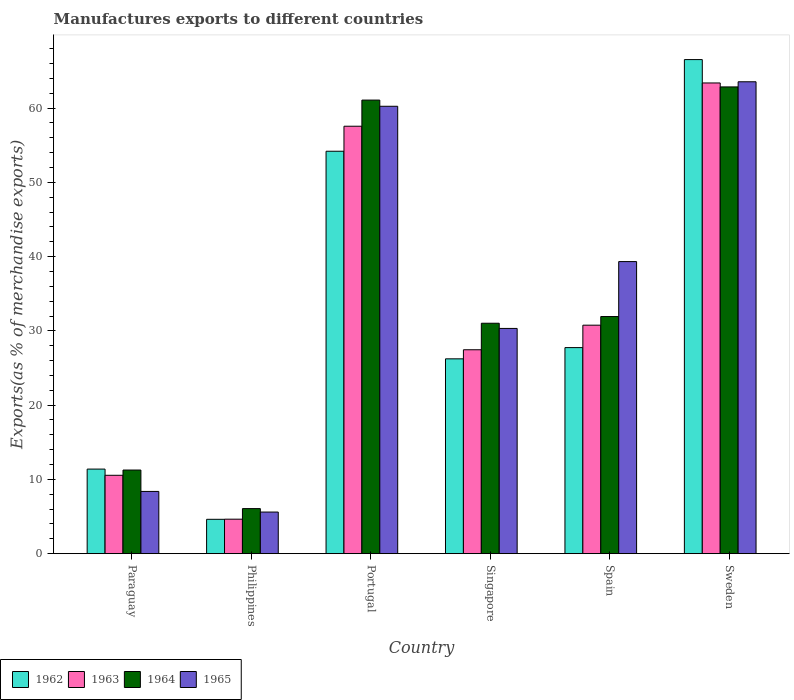How many different coloured bars are there?
Ensure brevity in your answer.  4. How many groups of bars are there?
Your answer should be very brief. 6. How many bars are there on the 5th tick from the left?
Offer a terse response. 4. What is the label of the 4th group of bars from the left?
Provide a succinct answer. Singapore. In how many cases, is the number of bars for a given country not equal to the number of legend labels?
Your response must be concise. 0. What is the percentage of exports to different countries in 1963 in Paraguay?
Offer a terse response. 10.55. Across all countries, what is the maximum percentage of exports to different countries in 1963?
Keep it short and to the point. 63.39. Across all countries, what is the minimum percentage of exports to different countries in 1962?
Your response must be concise. 4.63. In which country was the percentage of exports to different countries in 1962 maximum?
Make the answer very short. Sweden. What is the total percentage of exports to different countries in 1965 in the graph?
Offer a terse response. 207.45. What is the difference between the percentage of exports to different countries in 1963 in Philippines and that in Spain?
Give a very brief answer. -26.13. What is the difference between the percentage of exports to different countries in 1963 in Paraguay and the percentage of exports to different countries in 1965 in Portugal?
Your answer should be compact. -49.7. What is the average percentage of exports to different countries in 1964 per country?
Your response must be concise. 34.04. What is the difference between the percentage of exports to different countries of/in 1965 and percentage of exports to different countries of/in 1962 in Spain?
Offer a very short reply. 11.58. In how many countries, is the percentage of exports to different countries in 1965 greater than 40 %?
Make the answer very short. 2. What is the ratio of the percentage of exports to different countries in 1964 in Portugal to that in Spain?
Keep it short and to the point. 1.91. Is the difference between the percentage of exports to different countries in 1965 in Paraguay and Philippines greater than the difference between the percentage of exports to different countries in 1962 in Paraguay and Philippines?
Provide a succinct answer. No. What is the difference between the highest and the second highest percentage of exports to different countries in 1964?
Offer a terse response. -1.77. What is the difference between the highest and the lowest percentage of exports to different countries in 1965?
Your answer should be compact. 57.95. Is it the case that in every country, the sum of the percentage of exports to different countries in 1962 and percentage of exports to different countries in 1963 is greater than the sum of percentage of exports to different countries in 1965 and percentage of exports to different countries in 1964?
Offer a very short reply. No. What does the 3rd bar from the left in Sweden represents?
Make the answer very short. 1964. What does the 1st bar from the right in Paraguay represents?
Keep it short and to the point. 1965. How many countries are there in the graph?
Provide a short and direct response. 6. Does the graph contain any zero values?
Ensure brevity in your answer.  No. How are the legend labels stacked?
Give a very brief answer. Horizontal. What is the title of the graph?
Give a very brief answer. Manufactures exports to different countries. Does "1991" appear as one of the legend labels in the graph?
Your answer should be very brief. No. What is the label or title of the Y-axis?
Offer a very short reply. Exports(as % of merchandise exports). What is the Exports(as % of merchandise exports) in 1962 in Paraguay?
Make the answer very short. 11.39. What is the Exports(as % of merchandise exports) of 1963 in Paraguay?
Offer a very short reply. 10.55. What is the Exports(as % of merchandise exports) in 1964 in Paraguay?
Offer a terse response. 11.26. What is the Exports(as % of merchandise exports) in 1965 in Paraguay?
Offer a very short reply. 8.38. What is the Exports(as % of merchandise exports) in 1962 in Philippines?
Your answer should be very brief. 4.63. What is the Exports(as % of merchandise exports) in 1963 in Philippines?
Provide a succinct answer. 4.64. What is the Exports(as % of merchandise exports) in 1964 in Philippines?
Offer a terse response. 6.07. What is the Exports(as % of merchandise exports) in 1965 in Philippines?
Your response must be concise. 5.6. What is the Exports(as % of merchandise exports) of 1962 in Portugal?
Provide a short and direct response. 54.19. What is the Exports(as % of merchandise exports) of 1963 in Portugal?
Ensure brevity in your answer.  57.56. What is the Exports(as % of merchandise exports) in 1964 in Portugal?
Your answer should be very brief. 61.08. What is the Exports(as % of merchandise exports) of 1965 in Portugal?
Ensure brevity in your answer.  60.25. What is the Exports(as % of merchandise exports) of 1962 in Singapore?
Your response must be concise. 26.24. What is the Exports(as % of merchandise exports) of 1963 in Singapore?
Your response must be concise. 27.46. What is the Exports(as % of merchandise exports) of 1964 in Singapore?
Offer a terse response. 31.03. What is the Exports(as % of merchandise exports) in 1965 in Singapore?
Offer a terse response. 30.33. What is the Exports(as % of merchandise exports) of 1962 in Spain?
Ensure brevity in your answer.  27.75. What is the Exports(as % of merchandise exports) in 1963 in Spain?
Give a very brief answer. 30.77. What is the Exports(as % of merchandise exports) of 1964 in Spain?
Keep it short and to the point. 31.93. What is the Exports(as % of merchandise exports) of 1965 in Spain?
Your answer should be compact. 39.33. What is the Exports(as % of merchandise exports) in 1962 in Sweden?
Offer a very short reply. 66.54. What is the Exports(as % of merchandise exports) of 1963 in Sweden?
Keep it short and to the point. 63.39. What is the Exports(as % of merchandise exports) in 1964 in Sweden?
Ensure brevity in your answer.  62.86. What is the Exports(as % of merchandise exports) of 1965 in Sweden?
Provide a succinct answer. 63.55. Across all countries, what is the maximum Exports(as % of merchandise exports) of 1962?
Keep it short and to the point. 66.54. Across all countries, what is the maximum Exports(as % of merchandise exports) of 1963?
Provide a succinct answer. 63.39. Across all countries, what is the maximum Exports(as % of merchandise exports) of 1964?
Make the answer very short. 62.86. Across all countries, what is the maximum Exports(as % of merchandise exports) in 1965?
Your response must be concise. 63.55. Across all countries, what is the minimum Exports(as % of merchandise exports) in 1962?
Offer a very short reply. 4.63. Across all countries, what is the minimum Exports(as % of merchandise exports) of 1963?
Ensure brevity in your answer.  4.64. Across all countries, what is the minimum Exports(as % of merchandise exports) in 1964?
Your answer should be compact. 6.07. Across all countries, what is the minimum Exports(as % of merchandise exports) of 1965?
Your answer should be very brief. 5.6. What is the total Exports(as % of merchandise exports) of 1962 in the graph?
Offer a very short reply. 190.73. What is the total Exports(as % of merchandise exports) in 1963 in the graph?
Provide a short and direct response. 194.38. What is the total Exports(as % of merchandise exports) in 1964 in the graph?
Your answer should be very brief. 204.23. What is the total Exports(as % of merchandise exports) in 1965 in the graph?
Keep it short and to the point. 207.45. What is the difference between the Exports(as % of merchandise exports) in 1962 in Paraguay and that in Philippines?
Ensure brevity in your answer.  6.76. What is the difference between the Exports(as % of merchandise exports) in 1963 in Paraguay and that in Philippines?
Make the answer very short. 5.91. What is the difference between the Exports(as % of merchandise exports) of 1964 in Paraguay and that in Philippines?
Ensure brevity in your answer.  5.19. What is the difference between the Exports(as % of merchandise exports) of 1965 in Paraguay and that in Philippines?
Your answer should be very brief. 2.78. What is the difference between the Exports(as % of merchandise exports) of 1962 in Paraguay and that in Portugal?
Provide a short and direct response. -42.8. What is the difference between the Exports(as % of merchandise exports) of 1963 in Paraguay and that in Portugal?
Keep it short and to the point. -47.01. What is the difference between the Exports(as % of merchandise exports) of 1964 in Paraguay and that in Portugal?
Provide a succinct answer. -49.82. What is the difference between the Exports(as % of merchandise exports) of 1965 in Paraguay and that in Portugal?
Your answer should be very brief. -51.87. What is the difference between the Exports(as % of merchandise exports) of 1962 in Paraguay and that in Singapore?
Your answer should be compact. -14.85. What is the difference between the Exports(as % of merchandise exports) in 1963 in Paraguay and that in Singapore?
Offer a very short reply. -16.91. What is the difference between the Exports(as % of merchandise exports) in 1964 in Paraguay and that in Singapore?
Your answer should be very brief. -19.77. What is the difference between the Exports(as % of merchandise exports) in 1965 in Paraguay and that in Singapore?
Your response must be concise. -21.95. What is the difference between the Exports(as % of merchandise exports) in 1962 in Paraguay and that in Spain?
Offer a terse response. -16.36. What is the difference between the Exports(as % of merchandise exports) of 1963 in Paraguay and that in Spain?
Provide a short and direct response. -20.22. What is the difference between the Exports(as % of merchandise exports) in 1964 in Paraguay and that in Spain?
Provide a short and direct response. -20.67. What is the difference between the Exports(as % of merchandise exports) in 1965 in Paraguay and that in Spain?
Offer a very short reply. -30.95. What is the difference between the Exports(as % of merchandise exports) in 1962 in Paraguay and that in Sweden?
Ensure brevity in your answer.  -55.15. What is the difference between the Exports(as % of merchandise exports) of 1963 in Paraguay and that in Sweden?
Provide a short and direct response. -52.83. What is the difference between the Exports(as % of merchandise exports) in 1964 in Paraguay and that in Sweden?
Your answer should be compact. -51.6. What is the difference between the Exports(as % of merchandise exports) of 1965 in Paraguay and that in Sweden?
Provide a succinct answer. -55.17. What is the difference between the Exports(as % of merchandise exports) of 1962 in Philippines and that in Portugal?
Your answer should be very brief. -49.57. What is the difference between the Exports(as % of merchandise exports) in 1963 in Philippines and that in Portugal?
Provide a succinct answer. -52.92. What is the difference between the Exports(as % of merchandise exports) in 1964 in Philippines and that in Portugal?
Your response must be concise. -55.02. What is the difference between the Exports(as % of merchandise exports) in 1965 in Philippines and that in Portugal?
Your answer should be very brief. -54.65. What is the difference between the Exports(as % of merchandise exports) in 1962 in Philippines and that in Singapore?
Make the answer very short. -21.61. What is the difference between the Exports(as % of merchandise exports) in 1963 in Philippines and that in Singapore?
Provide a succinct answer. -22.82. What is the difference between the Exports(as % of merchandise exports) in 1964 in Philippines and that in Singapore?
Keep it short and to the point. -24.96. What is the difference between the Exports(as % of merchandise exports) in 1965 in Philippines and that in Singapore?
Ensure brevity in your answer.  -24.73. What is the difference between the Exports(as % of merchandise exports) of 1962 in Philippines and that in Spain?
Offer a terse response. -23.12. What is the difference between the Exports(as % of merchandise exports) in 1963 in Philippines and that in Spain?
Give a very brief answer. -26.13. What is the difference between the Exports(as % of merchandise exports) in 1964 in Philippines and that in Spain?
Offer a terse response. -25.87. What is the difference between the Exports(as % of merchandise exports) in 1965 in Philippines and that in Spain?
Your response must be concise. -33.73. What is the difference between the Exports(as % of merchandise exports) of 1962 in Philippines and that in Sweden?
Ensure brevity in your answer.  -61.91. What is the difference between the Exports(as % of merchandise exports) in 1963 in Philippines and that in Sweden?
Your answer should be very brief. -58.74. What is the difference between the Exports(as % of merchandise exports) in 1964 in Philippines and that in Sweden?
Provide a succinct answer. -56.79. What is the difference between the Exports(as % of merchandise exports) of 1965 in Philippines and that in Sweden?
Your response must be concise. -57.95. What is the difference between the Exports(as % of merchandise exports) in 1962 in Portugal and that in Singapore?
Keep it short and to the point. 27.96. What is the difference between the Exports(as % of merchandise exports) in 1963 in Portugal and that in Singapore?
Your answer should be compact. 30.1. What is the difference between the Exports(as % of merchandise exports) in 1964 in Portugal and that in Singapore?
Your answer should be very brief. 30.05. What is the difference between the Exports(as % of merchandise exports) in 1965 in Portugal and that in Singapore?
Offer a terse response. 29.92. What is the difference between the Exports(as % of merchandise exports) in 1962 in Portugal and that in Spain?
Provide a succinct answer. 26.44. What is the difference between the Exports(as % of merchandise exports) of 1963 in Portugal and that in Spain?
Give a very brief answer. 26.79. What is the difference between the Exports(as % of merchandise exports) in 1964 in Portugal and that in Spain?
Ensure brevity in your answer.  29.15. What is the difference between the Exports(as % of merchandise exports) in 1965 in Portugal and that in Spain?
Give a very brief answer. 20.92. What is the difference between the Exports(as % of merchandise exports) in 1962 in Portugal and that in Sweden?
Your answer should be compact. -12.35. What is the difference between the Exports(as % of merchandise exports) in 1963 in Portugal and that in Sweden?
Offer a terse response. -5.83. What is the difference between the Exports(as % of merchandise exports) in 1964 in Portugal and that in Sweden?
Keep it short and to the point. -1.77. What is the difference between the Exports(as % of merchandise exports) of 1965 in Portugal and that in Sweden?
Keep it short and to the point. -3.3. What is the difference between the Exports(as % of merchandise exports) of 1962 in Singapore and that in Spain?
Provide a short and direct response. -1.51. What is the difference between the Exports(as % of merchandise exports) in 1963 in Singapore and that in Spain?
Make the answer very short. -3.31. What is the difference between the Exports(as % of merchandise exports) in 1964 in Singapore and that in Spain?
Provide a succinct answer. -0.9. What is the difference between the Exports(as % of merchandise exports) in 1965 in Singapore and that in Spain?
Make the answer very short. -9. What is the difference between the Exports(as % of merchandise exports) of 1962 in Singapore and that in Sweden?
Keep it short and to the point. -40.3. What is the difference between the Exports(as % of merchandise exports) in 1963 in Singapore and that in Sweden?
Your response must be concise. -35.93. What is the difference between the Exports(as % of merchandise exports) in 1964 in Singapore and that in Sweden?
Provide a succinct answer. -31.83. What is the difference between the Exports(as % of merchandise exports) of 1965 in Singapore and that in Sweden?
Ensure brevity in your answer.  -33.22. What is the difference between the Exports(as % of merchandise exports) in 1962 in Spain and that in Sweden?
Make the answer very short. -38.79. What is the difference between the Exports(as % of merchandise exports) in 1963 in Spain and that in Sweden?
Your response must be concise. -32.62. What is the difference between the Exports(as % of merchandise exports) of 1964 in Spain and that in Sweden?
Provide a short and direct response. -30.92. What is the difference between the Exports(as % of merchandise exports) in 1965 in Spain and that in Sweden?
Your response must be concise. -24.22. What is the difference between the Exports(as % of merchandise exports) of 1962 in Paraguay and the Exports(as % of merchandise exports) of 1963 in Philippines?
Your answer should be compact. 6.75. What is the difference between the Exports(as % of merchandise exports) in 1962 in Paraguay and the Exports(as % of merchandise exports) in 1964 in Philippines?
Offer a very short reply. 5.32. What is the difference between the Exports(as % of merchandise exports) of 1962 in Paraguay and the Exports(as % of merchandise exports) of 1965 in Philippines?
Provide a short and direct response. 5.79. What is the difference between the Exports(as % of merchandise exports) of 1963 in Paraguay and the Exports(as % of merchandise exports) of 1964 in Philippines?
Offer a very short reply. 4.49. What is the difference between the Exports(as % of merchandise exports) in 1963 in Paraguay and the Exports(as % of merchandise exports) in 1965 in Philippines?
Offer a terse response. 4.95. What is the difference between the Exports(as % of merchandise exports) of 1964 in Paraguay and the Exports(as % of merchandise exports) of 1965 in Philippines?
Keep it short and to the point. 5.66. What is the difference between the Exports(as % of merchandise exports) in 1962 in Paraguay and the Exports(as % of merchandise exports) in 1963 in Portugal?
Offer a terse response. -46.17. What is the difference between the Exports(as % of merchandise exports) of 1962 in Paraguay and the Exports(as % of merchandise exports) of 1964 in Portugal?
Your response must be concise. -49.69. What is the difference between the Exports(as % of merchandise exports) of 1962 in Paraguay and the Exports(as % of merchandise exports) of 1965 in Portugal?
Your answer should be very brief. -48.86. What is the difference between the Exports(as % of merchandise exports) in 1963 in Paraguay and the Exports(as % of merchandise exports) in 1964 in Portugal?
Offer a very short reply. -50.53. What is the difference between the Exports(as % of merchandise exports) in 1963 in Paraguay and the Exports(as % of merchandise exports) in 1965 in Portugal?
Your answer should be very brief. -49.7. What is the difference between the Exports(as % of merchandise exports) in 1964 in Paraguay and the Exports(as % of merchandise exports) in 1965 in Portugal?
Your response must be concise. -48.99. What is the difference between the Exports(as % of merchandise exports) in 1962 in Paraguay and the Exports(as % of merchandise exports) in 1963 in Singapore?
Provide a short and direct response. -16.07. What is the difference between the Exports(as % of merchandise exports) in 1962 in Paraguay and the Exports(as % of merchandise exports) in 1964 in Singapore?
Give a very brief answer. -19.64. What is the difference between the Exports(as % of merchandise exports) of 1962 in Paraguay and the Exports(as % of merchandise exports) of 1965 in Singapore?
Provide a short and direct response. -18.94. What is the difference between the Exports(as % of merchandise exports) of 1963 in Paraguay and the Exports(as % of merchandise exports) of 1964 in Singapore?
Your answer should be very brief. -20.48. What is the difference between the Exports(as % of merchandise exports) of 1963 in Paraguay and the Exports(as % of merchandise exports) of 1965 in Singapore?
Offer a very short reply. -19.78. What is the difference between the Exports(as % of merchandise exports) in 1964 in Paraguay and the Exports(as % of merchandise exports) in 1965 in Singapore?
Provide a short and direct response. -19.07. What is the difference between the Exports(as % of merchandise exports) in 1962 in Paraguay and the Exports(as % of merchandise exports) in 1963 in Spain?
Provide a succinct answer. -19.38. What is the difference between the Exports(as % of merchandise exports) of 1962 in Paraguay and the Exports(as % of merchandise exports) of 1964 in Spain?
Provide a short and direct response. -20.54. What is the difference between the Exports(as % of merchandise exports) in 1962 in Paraguay and the Exports(as % of merchandise exports) in 1965 in Spain?
Provide a short and direct response. -27.94. What is the difference between the Exports(as % of merchandise exports) of 1963 in Paraguay and the Exports(as % of merchandise exports) of 1964 in Spain?
Ensure brevity in your answer.  -21.38. What is the difference between the Exports(as % of merchandise exports) of 1963 in Paraguay and the Exports(as % of merchandise exports) of 1965 in Spain?
Keep it short and to the point. -28.78. What is the difference between the Exports(as % of merchandise exports) in 1964 in Paraguay and the Exports(as % of merchandise exports) in 1965 in Spain?
Offer a terse response. -28.07. What is the difference between the Exports(as % of merchandise exports) in 1962 in Paraguay and the Exports(as % of merchandise exports) in 1963 in Sweden?
Your answer should be very brief. -52. What is the difference between the Exports(as % of merchandise exports) in 1962 in Paraguay and the Exports(as % of merchandise exports) in 1964 in Sweden?
Make the answer very short. -51.47. What is the difference between the Exports(as % of merchandise exports) in 1962 in Paraguay and the Exports(as % of merchandise exports) in 1965 in Sweden?
Provide a succinct answer. -52.16. What is the difference between the Exports(as % of merchandise exports) of 1963 in Paraguay and the Exports(as % of merchandise exports) of 1964 in Sweden?
Offer a terse response. -52.3. What is the difference between the Exports(as % of merchandise exports) of 1963 in Paraguay and the Exports(as % of merchandise exports) of 1965 in Sweden?
Your answer should be very brief. -52.99. What is the difference between the Exports(as % of merchandise exports) of 1964 in Paraguay and the Exports(as % of merchandise exports) of 1965 in Sweden?
Your answer should be very brief. -52.29. What is the difference between the Exports(as % of merchandise exports) of 1962 in Philippines and the Exports(as % of merchandise exports) of 1963 in Portugal?
Ensure brevity in your answer.  -52.93. What is the difference between the Exports(as % of merchandise exports) in 1962 in Philippines and the Exports(as % of merchandise exports) in 1964 in Portugal?
Provide a short and direct response. -56.46. What is the difference between the Exports(as % of merchandise exports) of 1962 in Philippines and the Exports(as % of merchandise exports) of 1965 in Portugal?
Your answer should be compact. -55.62. What is the difference between the Exports(as % of merchandise exports) of 1963 in Philippines and the Exports(as % of merchandise exports) of 1964 in Portugal?
Your answer should be compact. -56.44. What is the difference between the Exports(as % of merchandise exports) in 1963 in Philippines and the Exports(as % of merchandise exports) in 1965 in Portugal?
Your answer should be very brief. -55.61. What is the difference between the Exports(as % of merchandise exports) in 1964 in Philippines and the Exports(as % of merchandise exports) in 1965 in Portugal?
Provide a short and direct response. -54.18. What is the difference between the Exports(as % of merchandise exports) of 1962 in Philippines and the Exports(as % of merchandise exports) of 1963 in Singapore?
Provide a succinct answer. -22.83. What is the difference between the Exports(as % of merchandise exports) in 1962 in Philippines and the Exports(as % of merchandise exports) in 1964 in Singapore?
Provide a short and direct response. -26.4. What is the difference between the Exports(as % of merchandise exports) in 1962 in Philippines and the Exports(as % of merchandise exports) in 1965 in Singapore?
Offer a very short reply. -25.7. What is the difference between the Exports(as % of merchandise exports) in 1963 in Philippines and the Exports(as % of merchandise exports) in 1964 in Singapore?
Your answer should be very brief. -26.39. What is the difference between the Exports(as % of merchandise exports) of 1963 in Philippines and the Exports(as % of merchandise exports) of 1965 in Singapore?
Provide a succinct answer. -25.69. What is the difference between the Exports(as % of merchandise exports) of 1964 in Philippines and the Exports(as % of merchandise exports) of 1965 in Singapore?
Offer a terse response. -24.27. What is the difference between the Exports(as % of merchandise exports) of 1962 in Philippines and the Exports(as % of merchandise exports) of 1963 in Spain?
Offer a very short reply. -26.14. What is the difference between the Exports(as % of merchandise exports) of 1962 in Philippines and the Exports(as % of merchandise exports) of 1964 in Spain?
Give a very brief answer. -27.31. What is the difference between the Exports(as % of merchandise exports) of 1962 in Philippines and the Exports(as % of merchandise exports) of 1965 in Spain?
Provide a succinct answer. -34.71. What is the difference between the Exports(as % of merchandise exports) of 1963 in Philippines and the Exports(as % of merchandise exports) of 1964 in Spain?
Your answer should be compact. -27.29. What is the difference between the Exports(as % of merchandise exports) of 1963 in Philippines and the Exports(as % of merchandise exports) of 1965 in Spain?
Give a very brief answer. -34.69. What is the difference between the Exports(as % of merchandise exports) in 1964 in Philippines and the Exports(as % of merchandise exports) in 1965 in Spain?
Offer a very short reply. -33.27. What is the difference between the Exports(as % of merchandise exports) in 1962 in Philippines and the Exports(as % of merchandise exports) in 1963 in Sweden?
Ensure brevity in your answer.  -58.76. What is the difference between the Exports(as % of merchandise exports) in 1962 in Philippines and the Exports(as % of merchandise exports) in 1964 in Sweden?
Keep it short and to the point. -58.23. What is the difference between the Exports(as % of merchandise exports) of 1962 in Philippines and the Exports(as % of merchandise exports) of 1965 in Sweden?
Give a very brief answer. -58.92. What is the difference between the Exports(as % of merchandise exports) of 1963 in Philippines and the Exports(as % of merchandise exports) of 1964 in Sweden?
Your response must be concise. -58.21. What is the difference between the Exports(as % of merchandise exports) in 1963 in Philippines and the Exports(as % of merchandise exports) in 1965 in Sweden?
Make the answer very short. -58.91. What is the difference between the Exports(as % of merchandise exports) in 1964 in Philippines and the Exports(as % of merchandise exports) in 1965 in Sweden?
Your answer should be very brief. -57.48. What is the difference between the Exports(as % of merchandise exports) in 1962 in Portugal and the Exports(as % of merchandise exports) in 1963 in Singapore?
Offer a very short reply. 26.73. What is the difference between the Exports(as % of merchandise exports) of 1962 in Portugal and the Exports(as % of merchandise exports) of 1964 in Singapore?
Your response must be concise. 23.16. What is the difference between the Exports(as % of merchandise exports) of 1962 in Portugal and the Exports(as % of merchandise exports) of 1965 in Singapore?
Keep it short and to the point. 23.86. What is the difference between the Exports(as % of merchandise exports) of 1963 in Portugal and the Exports(as % of merchandise exports) of 1964 in Singapore?
Provide a succinct answer. 26.53. What is the difference between the Exports(as % of merchandise exports) in 1963 in Portugal and the Exports(as % of merchandise exports) in 1965 in Singapore?
Your answer should be very brief. 27.23. What is the difference between the Exports(as % of merchandise exports) of 1964 in Portugal and the Exports(as % of merchandise exports) of 1965 in Singapore?
Ensure brevity in your answer.  30.75. What is the difference between the Exports(as % of merchandise exports) in 1962 in Portugal and the Exports(as % of merchandise exports) in 1963 in Spain?
Provide a short and direct response. 23.42. What is the difference between the Exports(as % of merchandise exports) in 1962 in Portugal and the Exports(as % of merchandise exports) in 1964 in Spain?
Keep it short and to the point. 22.26. What is the difference between the Exports(as % of merchandise exports) of 1962 in Portugal and the Exports(as % of merchandise exports) of 1965 in Spain?
Ensure brevity in your answer.  14.86. What is the difference between the Exports(as % of merchandise exports) in 1963 in Portugal and the Exports(as % of merchandise exports) in 1964 in Spain?
Your response must be concise. 25.63. What is the difference between the Exports(as % of merchandise exports) of 1963 in Portugal and the Exports(as % of merchandise exports) of 1965 in Spain?
Your answer should be compact. 18.23. What is the difference between the Exports(as % of merchandise exports) in 1964 in Portugal and the Exports(as % of merchandise exports) in 1965 in Spain?
Offer a very short reply. 21.75. What is the difference between the Exports(as % of merchandise exports) of 1962 in Portugal and the Exports(as % of merchandise exports) of 1963 in Sweden?
Give a very brief answer. -9.2. What is the difference between the Exports(as % of merchandise exports) in 1962 in Portugal and the Exports(as % of merchandise exports) in 1964 in Sweden?
Give a very brief answer. -8.66. What is the difference between the Exports(as % of merchandise exports) of 1962 in Portugal and the Exports(as % of merchandise exports) of 1965 in Sweden?
Your answer should be very brief. -9.36. What is the difference between the Exports(as % of merchandise exports) in 1963 in Portugal and the Exports(as % of merchandise exports) in 1964 in Sweden?
Your response must be concise. -5.3. What is the difference between the Exports(as % of merchandise exports) of 1963 in Portugal and the Exports(as % of merchandise exports) of 1965 in Sweden?
Your answer should be very brief. -5.99. What is the difference between the Exports(as % of merchandise exports) of 1964 in Portugal and the Exports(as % of merchandise exports) of 1965 in Sweden?
Provide a succinct answer. -2.47. What is the difference between the Exports(as % of merchandise exports) of 1962 in Singapore and the Exports(as % of merchandise exports) of 1963 in Spain?
Provide a succinct answer. -4.53. What is the difference between the Exports(as % of merchandise exports) of 1962 in Singapore and the Exports(as % of merchandise exports) of 1964 in Spain?
Give a very brief answer. -5.7. What is the difference between the Exports(as % of merchandise exports) of 1962 in Singapore and the Exports(as % of merchandise exports) of 1965 in Spain?
Offer a very short reply. -13.1. What is the difference between the Exports(as % of merchandise exports) of 1963 in Singapore and the Exports(as % of merchandise exports) of 1964 in Spain?
Provide a short and direct response. -4.47. What is the difference between the Exports(as % of merchandise exports) in 1963 in Singapore and the Exports(as % of merchandise exports) in 1965 in Spain?
Provide a short and direct response. -11.87. What is the difference between the Exports(as % of merchandise exports) of 1964 in Singapore and the Exports(as % of merchandise exports) of 1965 in Spain?
Offer a terse response. -8.3. What is the difference between the Exports(as % of merchandise exports) of 1962 in Singapore and the Exports(as % of merchandise exports) of 1963 in Sweden?
Ensure brevity in your answer.  -37.15. What is the difference between the Exports(as % of merchandise exports) in 1962 in Singapore and the Exports(as % of merchandise exports) in 1964 in Sweden?
Provide a succinct answer. -36.62. What is the difference between the Exports(as % of merchandise exports) in 1962 in Singapore and the Exports(as % of merchandise exports) in 1965 in Sweden?
Ensure brevity in your answer.  -37.31. What is the difference between the Exports(as % of merchandise exports) of 1963 in Singapore and the Exports(as % of merchandise exports) of 1964 in Sweden?
Give a very brief answer. -35.4. What is the difference between the Exports(as % of merchandise exports) of 1963 in Singapore and the Exports(as % of merchandise exports) of 1965 in Sweden?
Offer a very short reply. -36.09. What is the difference between the Exports(as % of merchandise exports) in 1964 in Singapore and the Exports(as % of merchandise exports) in 1965 in Sweden?
Give a very brief answer. -32.52. What is the difference between the Exports(as % of merchandise exports) in 1962 in Spain and the Exports(as % of merchandise exports) in 1963 in Sweden?
Provide a succinct answer. -35.64. What is the difference between the Exports(as % of merchandise exports) in 1962 in Spain and the Exports(as % of merchandise exports) in 1964 in Sweden?
Give a very brief answer. -35.11. What is the difference between the Exports(as % of merchandise exports) in 1962 in Spain and the Exports(as % of merchandise exports) in 1965 in Sweden?
Make the answer very short. -35.8. What is the difference between the Exports(as % of merchandise exports) in 1963 in Spain and the Exports(as % of merchandise exports) in 1964 in Sweden?
Ensure brevity in your answer.  -32.09. What is the difference between the Exports(as % of merchandise exports) of 1963 in Spain and the Exports(as % of merchandise exports) of 1965 in Sweden?
Your answer should be compact. -32.78. What is the difference between the Exports(as % of merchandise exports) in 1964 in Spain and the Exports(as % of merchandise exports) in 1965 in Sweden?
Make the answer very short. -31.62. What is the average Exports(as % of merchandise exports) in 1962 per country?
Keep it short and to the point. 31.79. What is the average Exports(as % of merchandise exports) of 1963 per country?
Offer a terse response. 32.4. What is the average Exports(as % of merchandise exports) of 1964 per country?
Give a very brief answer. 34.04. What is the average Exports(as % of merchandise exports) of 1965 per country?
Offer a terse response. 34.57. What is the difference between the Exports(as % of merchandise exports) in 1962 and Exports(as % of merchandise exports) in 1963 in Paraguay?
Your answer should be very brief. 0.83. What is the difference between the Exports(as % of merchandise exports) of 1962 and Exports(as % of merchandise exports) of 1964 in Paraguay?
Give a very brief answer. 0.13. What is the difference between the Exports(as % of merchandise exports) in 1962 and Exports(as % of merchandise exports) in 1965 in Paraguay?
Give a very brief answer. 3.01. What is the difference between the Exports(as % of merchandise exports) of 1963 and Exports(as % of merchandise exports) of 1964 in Paraguay?
Offer a terse response. -0.71. What is the difference between the Exports(as % of merchandise exports) of 1963 and Exports(as % of merchandise exports) of 1965 in Paraguay?
Keep it short and to the point. 2.17. What is the difference between the Exports(as % of merchandise exports) in 1964 and Exports(as % of merchandise exports) in 1965 in Paraguay?
Offer a very short reply. 2.88. What is the difference between the Exports(as % of merchandise exports) in 1962 and Exports(as % of merchandise exports) in 1963 in Philippines?
Keep it short and to the point. -0.02. What is the difference between the Exports(as % of merchandise exports) in 1962 and Exports(as % of merchandise exports) in 1964 in Philippines?
Keep it short and to the point. -1.44. What is the difference between the Exports(as % of merchandise exports) in 1962 and Exports(as % of merchandise exports) in 1965 in Philippines?
Give a very brief answer. -0.98. What is the difference between the Exports(as % of merchandise exports) in 1963 and Exports(as % of merchandise exports) in 1964 in Philippines?
Give a very brief answer. -1.42. What is the difference between the Exports(as % of merchandise exports) in 1963 and Exports(as % of merchandise exports) in 1965 in Philippines?
Offer a terse response. -0.96. What is the difference between the Exports(as % of merchandise exports) of 1964 and Exports(as % of merchandise exports) of 1965 in Philippines?
Offer a very short reply. 0.46. What is the difference between the Exports(as % of merchandise exports) in 1962 and Exports(as % of merchandise exports) in 1963 in Portugal?
Your answer should be very brief. -3.37. What is the difference between the Exports(as % of merchandise exports) of 1962 and Exports(as % of merchandise exports) of 1964 in Portugal?
Your answer should be compact. -6.89. What is the difference between the Exports(as % of merchandise exports) of 1962 and Exports(as % of merchandise exports) of 1965 in Portugal?
Your response must be concise. -6.06. What is the difference between the Exports(as % of merchandise exports) in 1963 and Exports(as % of merchandise exports) in 1964 in Portugal?
Your answer should be very brief. -3.52. What is the difference between the Exports(as % of merchandise exports) in 1963 and Exports(as % of merchandise exports) in 1965 in Portugal?
Ensure brevity in your answer.  -2.69. What is the difference between the Exports(as % of merchandise exports) of 1964 and Exports(as % of merchandise exports) of 1965 in Portugal?
Your answer should be very brief. 0.83. What is the difference between the Exports(as % of merchandise exports) of 1962 and Exports(as % of merchandise exports) of 1963 in Singapore?
Keep it short and to the point. -1.22. What is the difference between the Exports(as % of merchandise exports) in 1962 and Exports(as % of merchandise exports) in 1964 in Singapore?
Ensure brevity in your answer.  -4.79. What is the difference between the Exports(as % of merchandise exports) of 1962 and Exports(as % of merchandise exports) of 1965 in Singapore?
Your response must be concise. -4.1. What is the difference between the Exports(as % of merchandise exports) in 1963 and Exports(as % of merchandise exports) in 1964 in Singapore?
Your answer should be very brief. -3.57. What is the difference between the Exports(as % of merchandise exports) in 1963 and Exports(as % of merchandise exports) in 1965 in Singapore?
Your answer should be compact. -2.87. What is the difference between the Exports(as % of merchandise exports) of 1964 and Exports(as % of merchandise exports) of 1965 in Singapore?
Keep it short and to the point. 0.7. What is the difference between the Exports(as % of merchandise exports) in 1962 and Exports(as % of merchandise exports) in 1963 in Spain?
Keep it short and to the point. -3.02. What is the difference between the Exports(as % of merchandise exports) of 1962 and Exports(as % of merchandise exports) of 1964 in Spain?
Your answer should be very brief. -4.18. What is the difference between the Exports(as % of merchandise exports) of 1962 and Exports(as % of merchandise exports) of 1965 in Spain?
Your answer should be compact. -11.58. What is the difference between the Exports(as % of merchandise exports) of 1963 and Exports(as % of merchandise exports) of 1964 in Spain?
Offer a terse response. -1.16. What is the difference between the Exports(as % of merchandise exports) of 1963 and Exports(as % of merchandise exports) of 1965 in Spain?
Ensure brevity in your answer.  -8.56. What is the difference between the Exports(as % of merchandise exports) in 1964 and Exports(as % of merchandise exports) in 1965 in Spain?
Make the answer very short. -7.4. What is the difference between the Exports(as % of merchandise exports) of 1962 and Exports(as % of merchandise exports) of 1963 in Sweden?
Give a very brief answer. 3.15. What is the difference between the Exports(as % of merchandise exports) of 1962 and Exports(as % of merchandise exports) of 1964 in Sweden?
Ensure brevity in your answer.  3.68. What is the difference between the Exports(as % of merchandise exports) of 1962 and Exports(as % of merchandise exports) of 1965 in Sweden?
Offer a very short reply. 2.99. What is the difference between the Exports(as % of merchandise exports) of 1963 and Exports(as % of merchandise exports) of 1964 in Sweden?
Your answer should be compact. 0.53. What is the difference between the Exports(as % of merchandise exports) in 1963 and Exports(as % of merchandise exports) in 1965 in Sweden?
Provide a short and direct response. -0.16. What is the difference between the Exports(as % of merchandise exports) of 1964 and Exports(as % of merchandise exports) of 1965 in Sweden?
Provide a short and direct response. -0.69. What is the ratio of the Exports(as % of merchandise exports) in 1962 in Paraguay to that in Philippines?
Keep it short and to the point. 2.46. What is the ratio of the Exports(as % of merchandise exports) of 1963 in Paraguay to that in Philippines?
Provide a succinct answer. 2.27. What is the ratio of the Exports(as % of merchandise exports) of 1964 in Paraguay to that in Philippines?
Give a very brief answer. 1.86. What is the ratio of the Exports(as % of merchandise exports) in 1965 in Paraguay to that in Philippines?
Give a very brief answer. 1.5. What is the ratio of the Exports(as % of merchandise exports) of 1962 in Paraguay to that in Portugal?
Provide a short and direct response. 0.21. What is the ratio of the Exports(as % of merchandise exports) in 1963 in Paraguay to that in Portugal?
Your answer should be very brief. 0.18. What is the ratio of the Exports(as % of merchandise exports) of 1964 in Paraguay to that in Portugal?
Your answer should be compact. 0.18. What is the ratio of the Exports(as % of merchandise exports) in 1965 in Paraguay to that in Portugal?
Your response must be concise. 0.14. What is the ratio of the Exports(as % of merchandise exports) in 1962 in Paraguay to that in Singapore?
Ensure brevity in your answer.  0.43. What is the ratio of the Exports(as % of merchandise exports) in 1963 in Paraguay to that in Singapore?
Ensure brevity in your answer.  0.38. What is the ratio of the Exports(as % of merchandise exports) of 1964 in Paraguay to that in Singapore?
Your response must be concise. 0.36. What is the ratio of the Exports(as % of merchandise exports) in 1965 in Paraguay to that in Singapore?
Provide a short and direct response. 0.28. What is the ratio of the Exports(as % of merchandise exports) of 1962 in Paraguay to that in Spain?
Offer a terse response. 0.41. What is the ratio of the Exports(as % of merchandise exports) of 1963 in Paraguay to that in Spain?
Your response must be concise. 0.34. What is the ratio of the Exports(as % of merchandise exports) in 1964 in Paraguay to that in Spain?
Make the answer very short. 0.35. What is the ratio of the Exports(as % of merchandise exports) in 1965 in Paraguay to that in Spain?
Provide a succinct answer. 0.21. What is the ratio of the Exports(as % of merchandise exports) in 1962 in Paraguay to that in Sweden?
Your answer should be very brief. 0.17. What is the ratio of the Exports(as % of merchandise exports) in 1963 in Paraguay to that in Sweden?
Provide a succinct answer. 0.17. What is the ratio of the Exports(as % of merchandise exports) of 1964 in Paraguay to that in Sweden?
Your answer should be very brief. 0.18. What is the ratio of the Exports(as % of merchandise exports) of 1965 in Paraguay to that in Sweden?
Offer a terse response. 0.13. What is the ratio of the Exports(as % of merchandise exports) in 1962 in Philippines to that in Portugal?
Your answer should be very brief. 0.09. What is the ratio of the Exports(as % of merchandise exports) in 1963 in Philippines to that in Portugal?
Provide a succinct answer. 0.08. What is the ratio of the Exports(as % of merchandise exports) of 1964 in Philippines to that in Portugal?
Your response must be concise. 0.1. What is the ratio of the Exports(as % of merchandise exports) in 1965 in Philippines to that in Portugal?
Offer a very short reply. 0.09. What is the ratio of the Exports(as % of merchandise exports) in 1962 in Philippines to that in Singapore?
Your answer should be compact. 0.18. What is the ratio of the Exports(as % of merchandise exports) of 1963 in Philippines to that in Singapore?
Keep it short and to the point. 0.17. What is the ratio of the Exports(as % of merchandise exports) in 1964 in Philippines to that in Singapore?
Provide a succinct answer. 0.2. What is the ratio of the Exports(as % of merchandise exports) in 1965 in Philippines to that in Singapore?
Give a very brief answer. 0.18. What is the ratio of the Exports(as % of merchandise exports) in 1962 in Philippines to that in Spain?
Your response must be concise. 0.17. What is the ratio of the Exports(as % of merchandise exports) in 1963 in Philippines to that in Spain?
Your response must be concise. 0.15. What is the ratio of the Exports(as % of merchandise exports) of 1964 in Philippines to that in Spain?
Provide a short and direct response. 0.19. What is the ratio of the Exports(as % of merchandise exports) of 1965 in Philippines to that in Spain?
Make the answer very short. 0.14. What is the ratio of the Exports(as % of merchandise exports) of 1962 in Philippines to that in Sweden?
Make the answer very short. 0.07. What is the ratio of the Exports(as % of merchandise exports) of 1963 in Philippines to that in Sweden?
Ensure brevity in your answer.  0.07. What is the ratio of the Exports(as % of merchandise exports) in 1964 in Philippines to that in Sweden?
Ensure brevity in your answer.  0.1. What is the ratio of the Exports(as % of merchandise exports) in 1965 in Philippines to that in Sweden?
Give a very brief answer. 0.09. What is the ratio of the Exports(as % of merchandise exports) of 1962 in Portugal to that in Singapore?
Give a very brief answer. 2.07. What is the ratio of the Exports(as % of merchandise exports) in 1963 in Portugal to that in Singapore?
Your response must be concise. 2.1. What is the ratio of the Exports(as % of merchandise exports) of 1964 in Portugal to that in Singapore?
Your answer should be very brief. 1.97. What is the ratio of the Exports(as % of merchandise exports) of 1965 in Portugal to that in Singapore?
Provide a succinct answer. 1.99. What is the ratio of the Exports(as % of merchandise exports) in 1962 in Portugal to that in Spain?
Your response must be concise. 1.95. What is the ratio of the Exports(as % of merchandise exports) in 1963 in Portugal to that in Spain?
Make the answer very short. 1.87. What is the ratio of the Exports(as % of merchandise exports) of 1964 in Portugal to that in Spain?
Provide a succinct answer. 1.91. What is the ratio of the Exports(as % of merchandise exports) of 1965 in Portugal to that in Spain?
Your answer should be compact. 1.53. What is the ratio of the Exports(as % of merchandise exports) in 1962 in Portugal to that in Sweden?
Provide a short and direct response. 0.81. What is the ratio of the Exports(as % of merchandise exports) in 1963 in Portugal to that in Sweden?
Give a very brief answer. 0.91. What is the ratio of the Exports(as % of merchandise exports) in 1964 in Portugal to that in Sweden?
Provide a short and direct response. 0.97. What is the ratio of the Exports(as % of merchandise exports) of 1965 in Portugal to that in Sweden?
Provide a short and direct response. 0.95. What is the ratio of the Exports(as % of merchandise exports) of 1962 in Singapore to that in Spain?
Your answer should be very brief. 0.95. What is the ratio of the Exports(as % of merchandise exports) of 1963 in Singapore to that in Spain?
Your answer should be very brief. 0.89. What is the ratio of the Exports(as % of merchandise exports) of 1964 in Singapore to that in Spain?
Your answer should be very brief. 0.97. What is the ratio of the Exports(as % of merchandise exports) in 1965 in Singapore to that in Spain?
Provide a succinct answer. 0.77. What is the ratio of the Exports(as % of merchandise exports) of 1962 in Singapore to that in Sweden?
Provide a short and direct response. 0.39. What is the ratio of the Exports(as % of merchandise exports) in 1963 in Singapore to that in Sweden?
Provide a short and direct response. 0.43. What is the ratio of the Exports(as % of merchandise exports) of 1964 in Singapore to that in Sweden?
Offer a terse response. 0.49. What is the ratio of the Exports(as % of merchandise exports) in 1965 in Singapore to that in Sweden?
Make the answer very short. 0.48. What is the ratio of the Exports(as % of merchandise exports) in 1962 in Spain to that in Sweden?
Your answer should be compact. 0.42. What is the ratio of the Exports(as % of merchandise exports) of 1963 in Spain to that in Sweden?
Ensure brevity in your answer.  0.49. What is the ratio of the Exports(as % of merchandise exports) in 1964 in Spain to that in Sweden?
Provide a short and direct response. 0.51. What is the ratio of the Exports(as % of merchandise exports) in 1965 in Spain to that in Sweden?
Your answer should be compact. 0.62. What is the difference between the highest and the second highest Exports(as % of merchandise exports) in 1962?
Provide a succinct answer. 12.35. What is the difference between the highest and the second highest Exports(as % of merchandise exports) of 1963?
Provide a succinct answer. 5.83. What is the difference between the highest and the second highest Exports(as % of merchandise exports) in 1964?
Offer a very short reply. 1.77. What is the difference between the highest and the second highest Exports(as % of merchandise exports) of 1965?
Ensure brevity in your answer.  3.3. What is the difference between the highest and the lowest Exports(as % of merchandise exports) of 1962?
Offer a terse response. 61.91. What is the difference between the highest and the lowest Exports(as % of merchandise exports) of 1963?
Your response must be concise. 58.74. What is the difference between the highest and the lowest Exports(as % of merchandise exports) of 1964?
Give a very brief answer. 56.79. What is the difference between the highest and the lowest Exports(as % of merchandise exports) of 1965?
Provide a succinct answer. 57.95. 